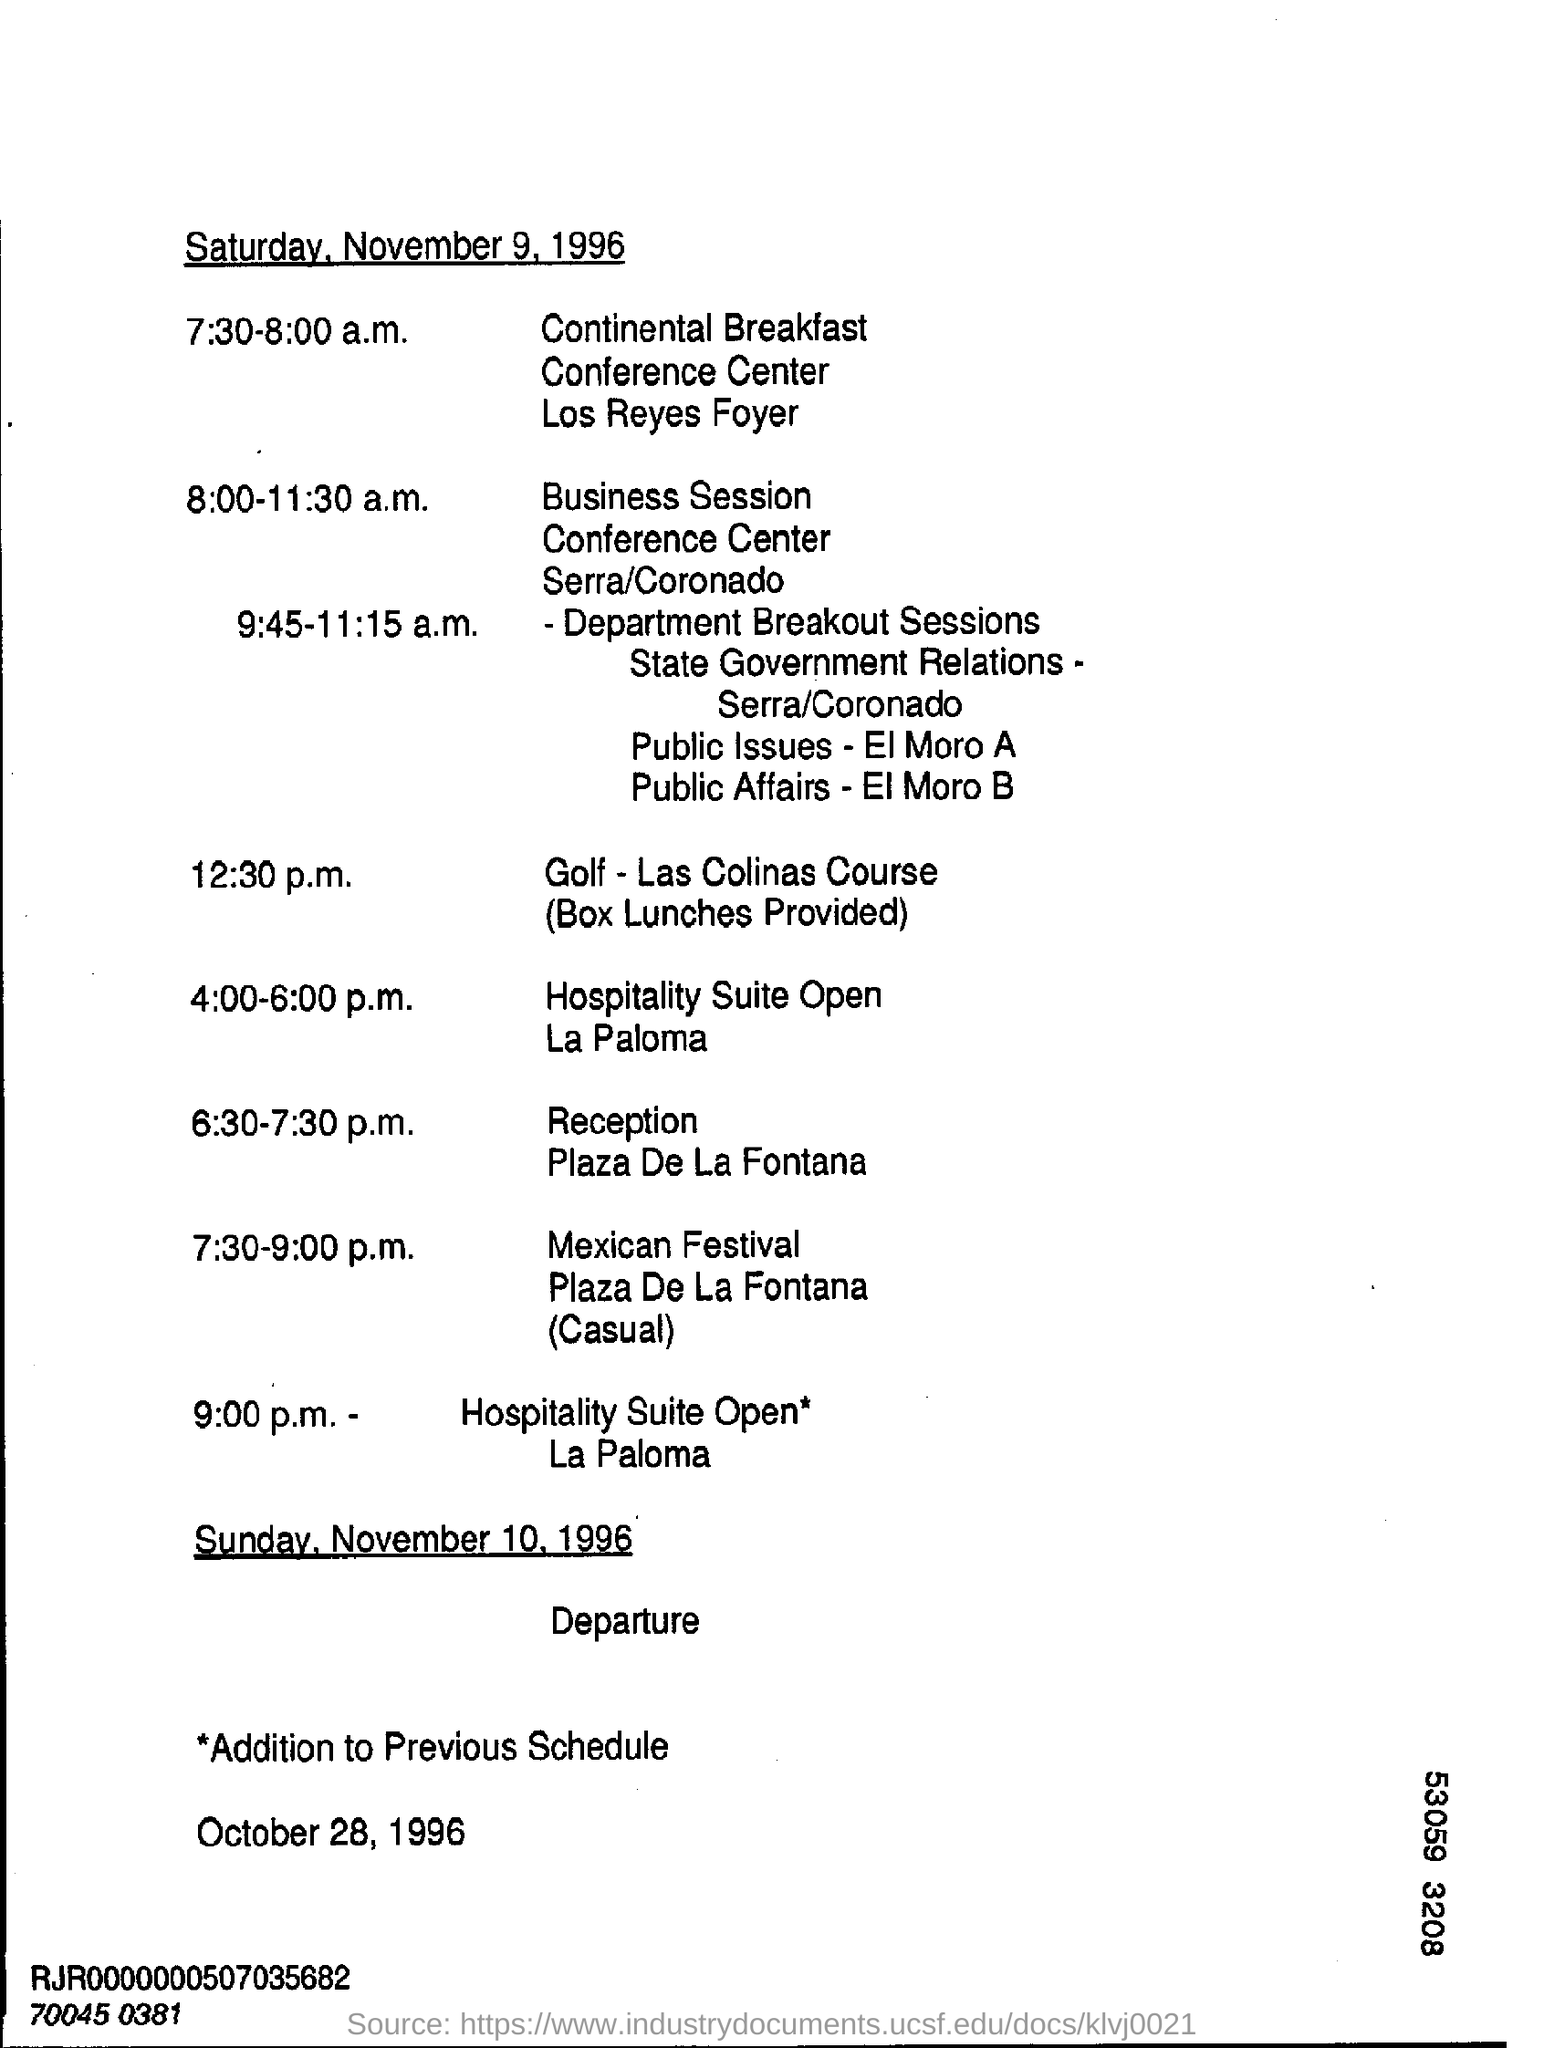What is the event at 12:30 p.m.?
Keep it short and to the point. Golf. At what time is the Reception?
Your response must be concise. 6:30-7:30 p.m. On which date is the departure?
Give a very brief answer. Sunday, November 10, 1996. 